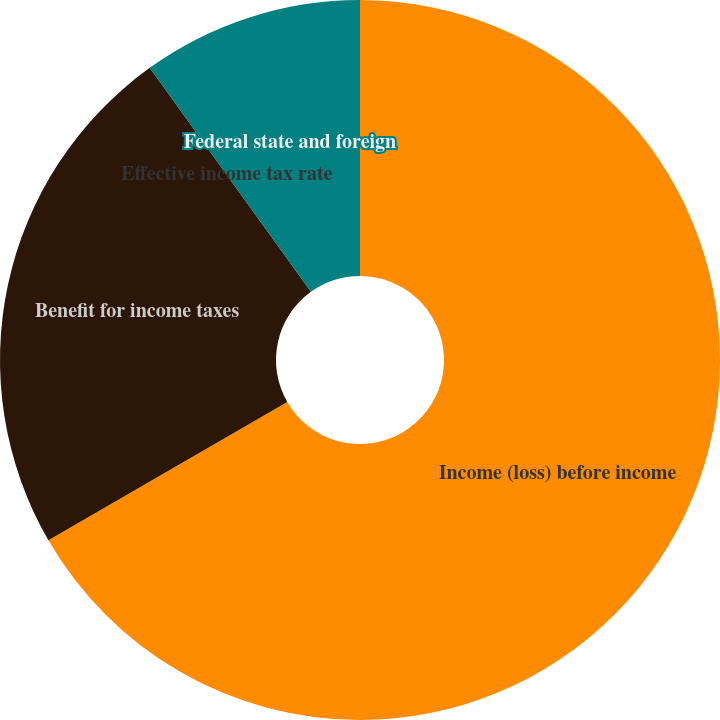Convert chart. <chart><loc_0><loc_0><loc_500><loc_500><pie_chart><fcel>Income (loss) before income<fcel>Benefit for income taxes<fcel>Effective income tax rate<fcel>Federal state and foreign<nl><fcel>66.65%<fcel>23.42%<fcel>0.0%<fcel>9.93%<nl></chart> 